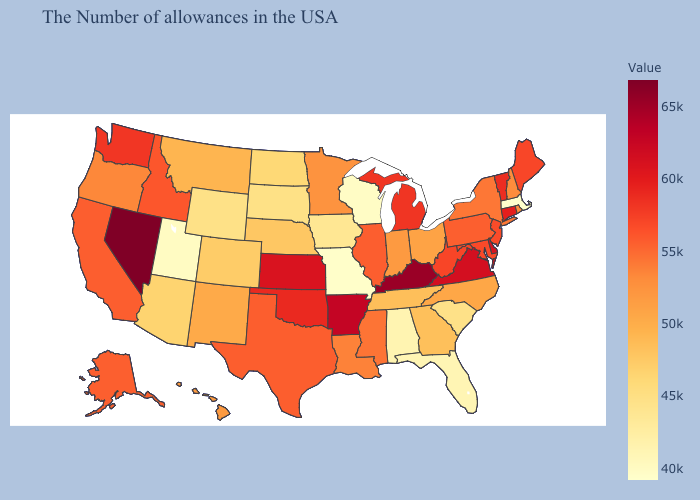Does the map have missing data?
Keep it brief. No. Which states have the highest value in the USA?
Answer briefly. Nevada. 